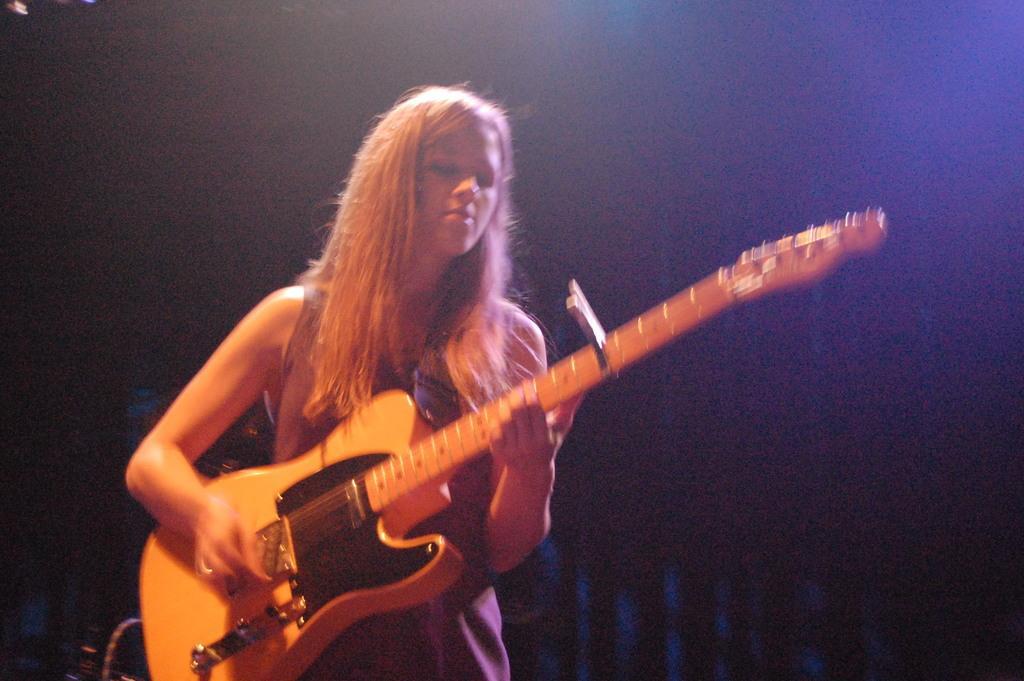Please provide a concise description of this image. In this picture there is a woman standing she is playing the guitar with her right hand and she is holding the guitar with left and in the background is a curtain 